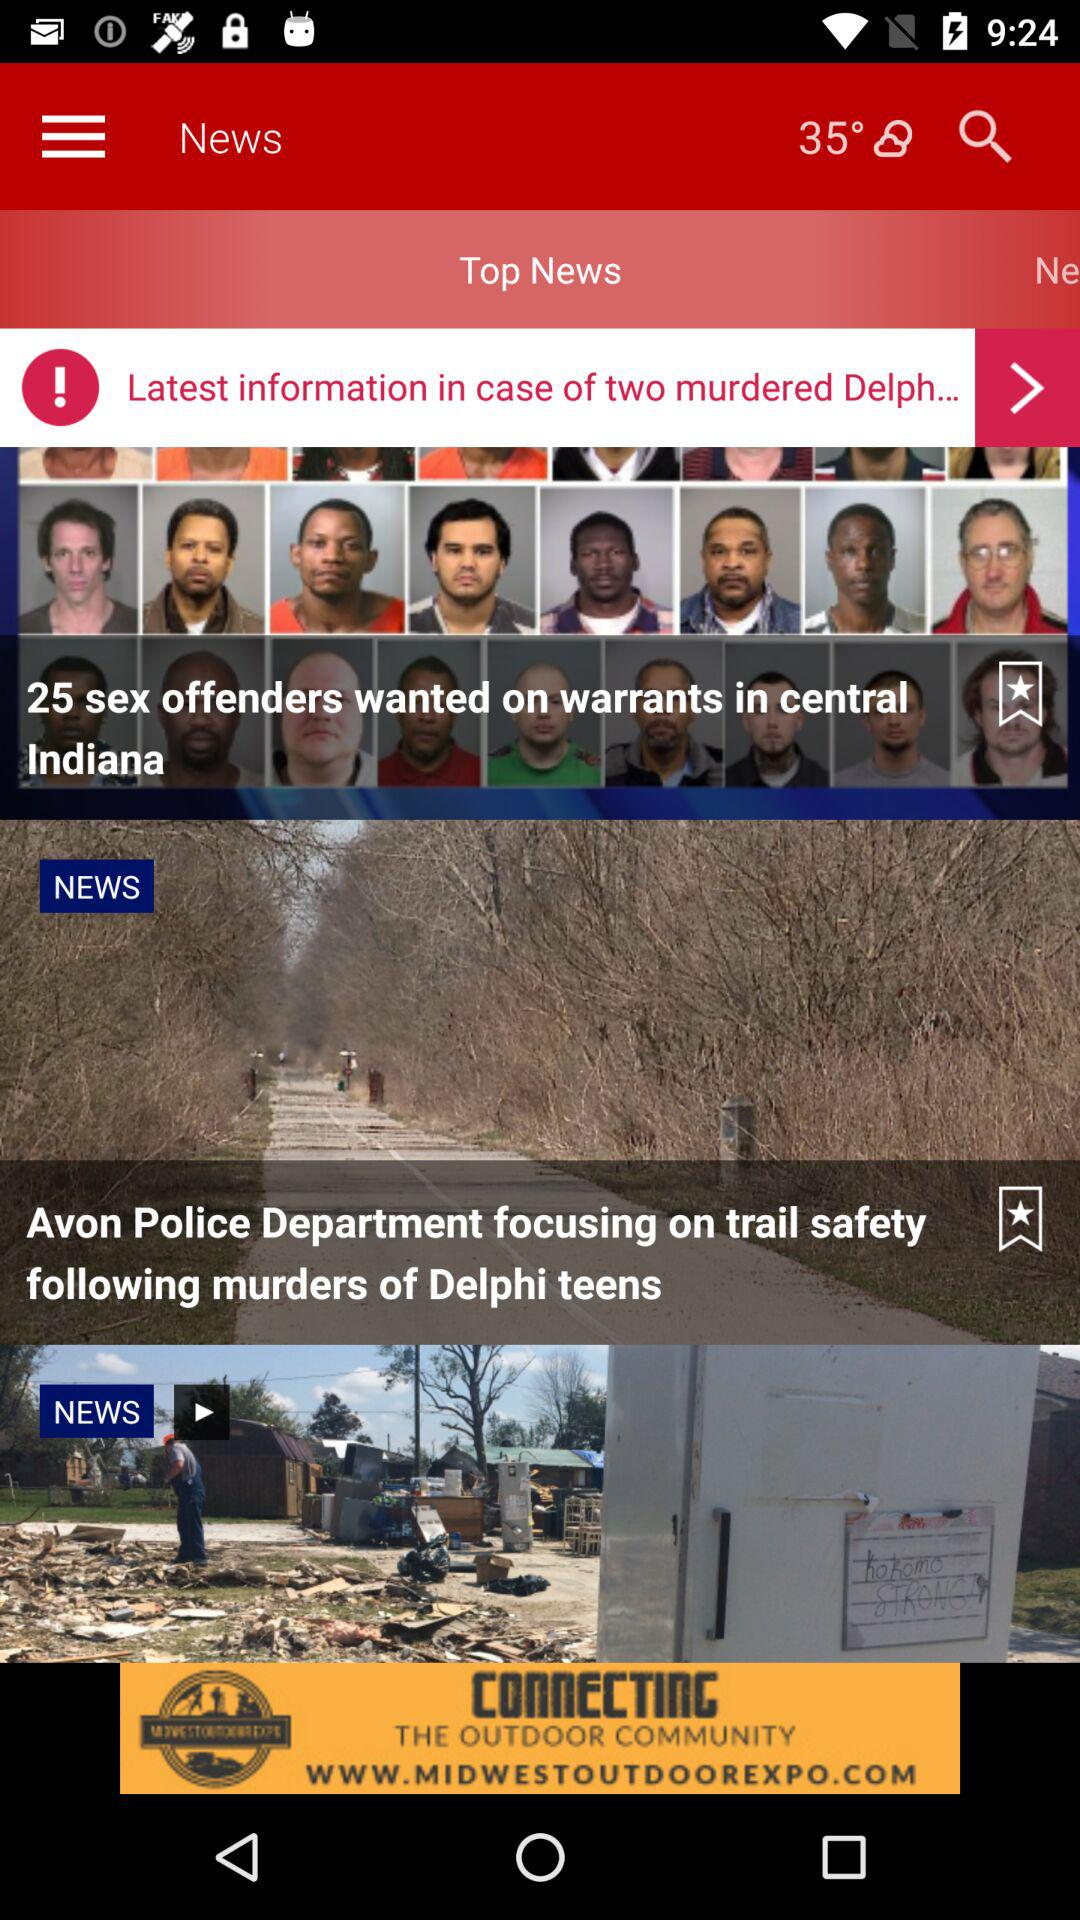Which are the different top news headlines? The different top news headlines are "25 sex offenders wanted on warrants in central Indiana" and "Avon Police Department focusing on trail safety following murders of Delphi teens". 